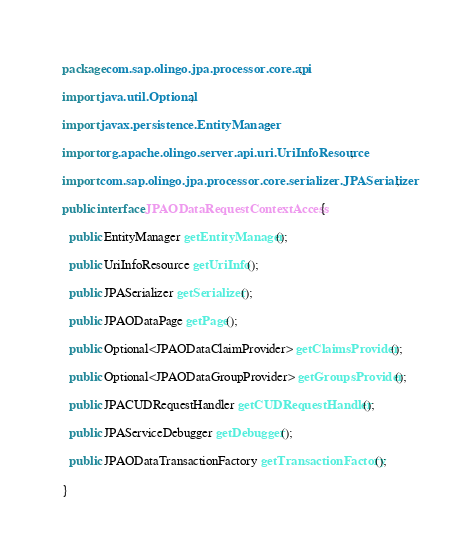Convert code to text. <code><loc_0><loc_0><loc_500><loc_500><_Java_>package com.sap.olingo.jpa.processor.core.api;

import java.util.Optional;

import javax.persistence.EntityManager;

import org.apache.olingo.server.api.uri.UriInfoResource;

import com.sap.olingo.jpa.processor.core.serializer.JPASerializer;

public interface JPAODataRequestContextAccess {

  public EntityManager getEntityManager();

  public UriInfoResource getUriInfo();

  public JPASerializer getSerializer();

  public JPAODataPage getPage();

  public Optional<JPAODataClaimProvider> getClaimsProvider();

  public Optional<JPAODataGroupProvider> getGroupsProvider();

  public JPACUDRequestHandler getCUDRequestHandler();

  public JPAServiceDebugger getDebugger();

  public JPAODataTransactionFactory getTransactionFactory();

}
</code> 